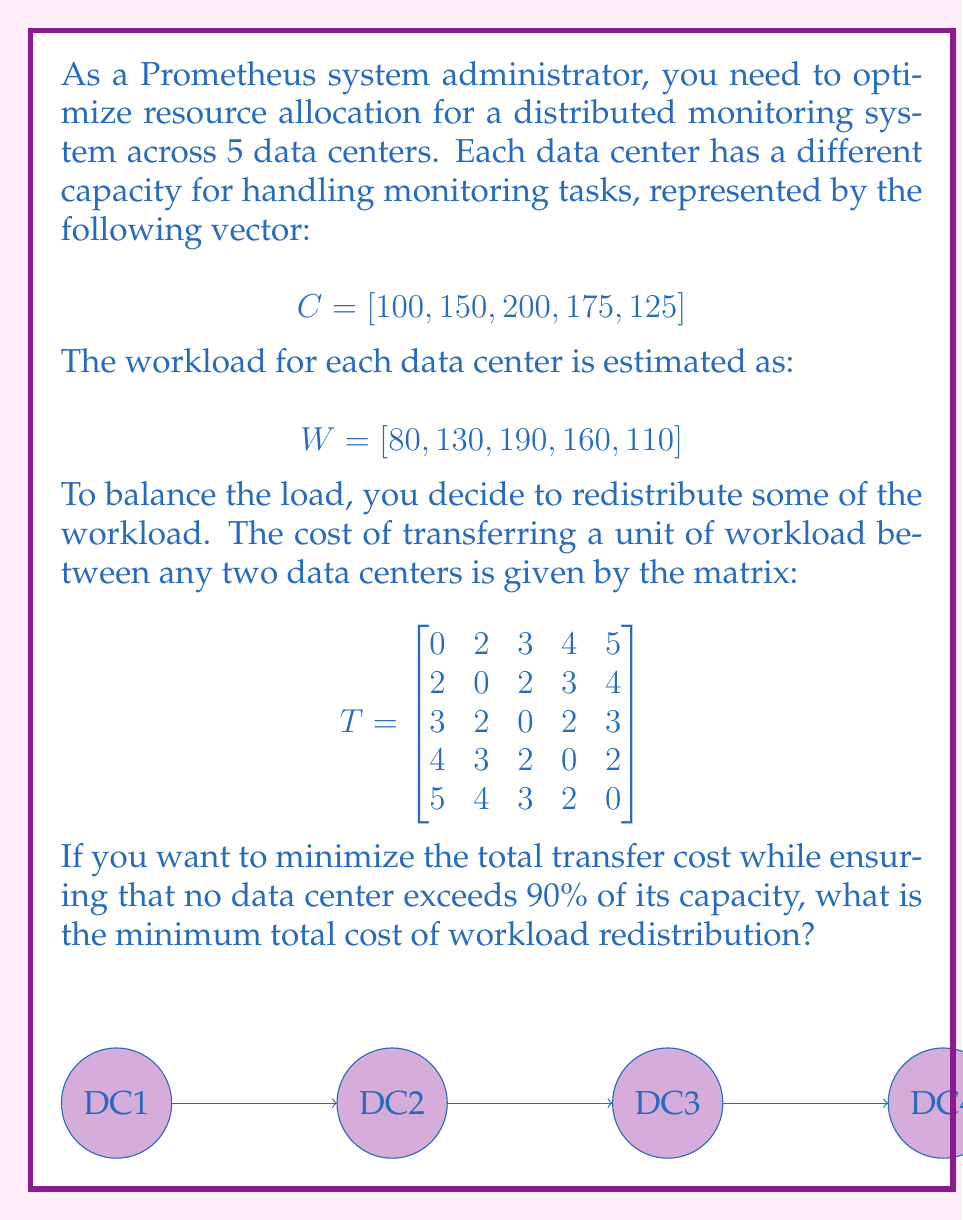Can you solve this math problem? Let's approach this step-by-step:

1) First, we need to calculate the maximum allowed workload for each data center at 90% capacity:

   $$ \text{Max Workload} = 0.9 \times C = [90, 135, 180, 157.5, 112.5] $$

2) Now, we can calculate the excess workload for each data center:

   $$ \text{Excess} = W - \text{Max Workload} = [-10, -5, 10, 2.5, -2.5] $$

   Negative values indicate capacity to receive workload, positive values indicate workload to be transferred.

3) We need to transfer 10 units from DC3 and 2.5 units from DC4. The receiving data centers can be DC1 (10 units) and DC2 (2.5 units).

4) Let's calculate the cost for each possible transfer:
   - DC3 to DC1: 10 × 3 = 30
   - DC3 to DC2: 10 × 2 = 20
   - DC4 to DC1: 2.5 × 4 = 10
   - DC4 to DC2: 2.5 × 3 = 7.5

5) To minimize the total cost, we should choose:
   - Transfer 10 units from DC3 to DC2: Cost = 20
   - Transfer 2.5 units from DC4 to DC2: Cost = 7.5

6) The total minimum cost is:

   $$ \text{Total Cost} = 20 + 7.5 = 27.5 $$
Answer: 27.5 